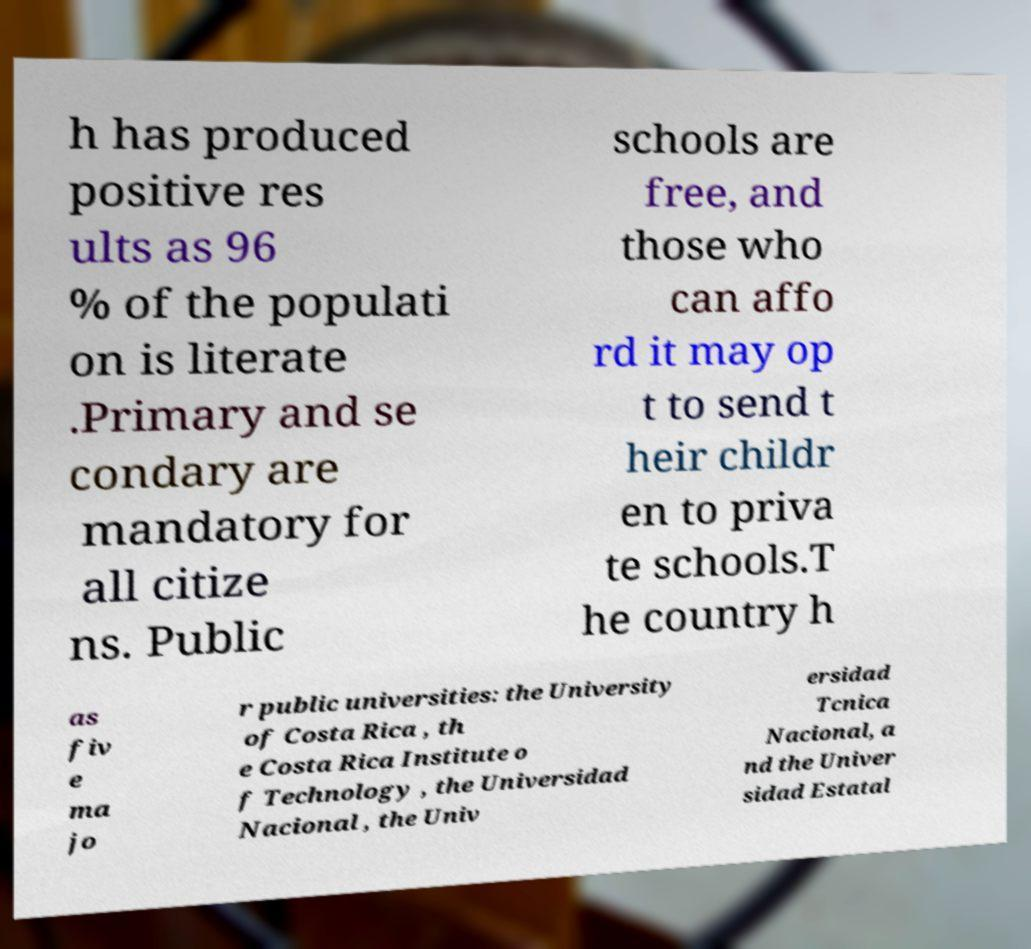Can you read and provide the text displayed in the image?This photo seems to have some interesting text. Can you extract and type it out for me? h has produced positive res ults as 96 % of the populati on is literate .Primary and se condary are mandatory for all citize ns. Public schools are free, and those who can affo rd it may op t to send t heir childr en to priva te schools.T he country h as fiv e ma jo r public universities: the University of Costa Rica , th e Costa Rica Institute o f Technology , the Universidad Nacional , the Univ ersidad Tcnica Nacional, a nd the Univer sidad Estatal 